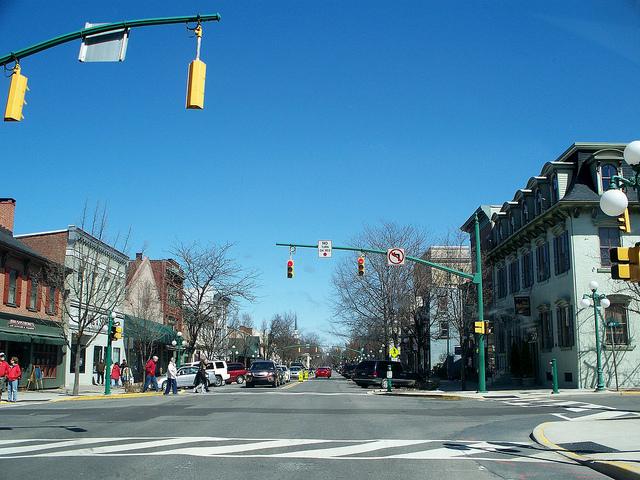Is a storm going on?
Write a very short answer. No. Are the people in red in uniforms?
Be succinct. No. What is the closest restaurant?
Concise answer only. Pub. Is the sun setting?
Be succinct. No. Is it cloudy?
Give a very brief answer. No. Is it ok to walk across the street?
Answer briefly. Yes. Can cars drive in the right lane?
Concise answer only. Yes. Where is the USPS box?
Answer briefly. Corner. What is the name on the building?
Quick response, please. None. Judging by the stoplight, is someone free to drive forward?
Short answer required. No. Is it a warm day?
Answer briefly. No. Is this a busy street?
Quick response, please. No. 